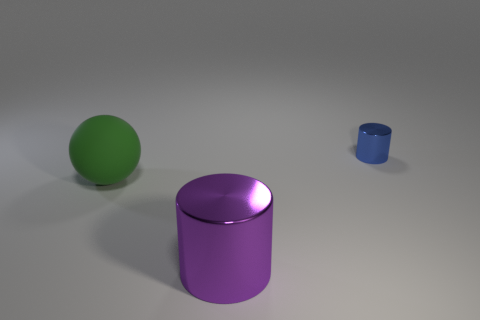Add 1 big purple metallic cylinders. How many objects exist? 4 Subtract all spheres. How many objects are left? 2 Subtract all large rubber objects. Subtract all big purple metal cylinders. How many objects are left? 1 Add 1 purple metal cylinders. How many purple metal cylinders are left? 2 Add 1 green matte spheres. How many green matte spheres exist? 2 Subtract 1 green spheres. How many objects are left? 2 